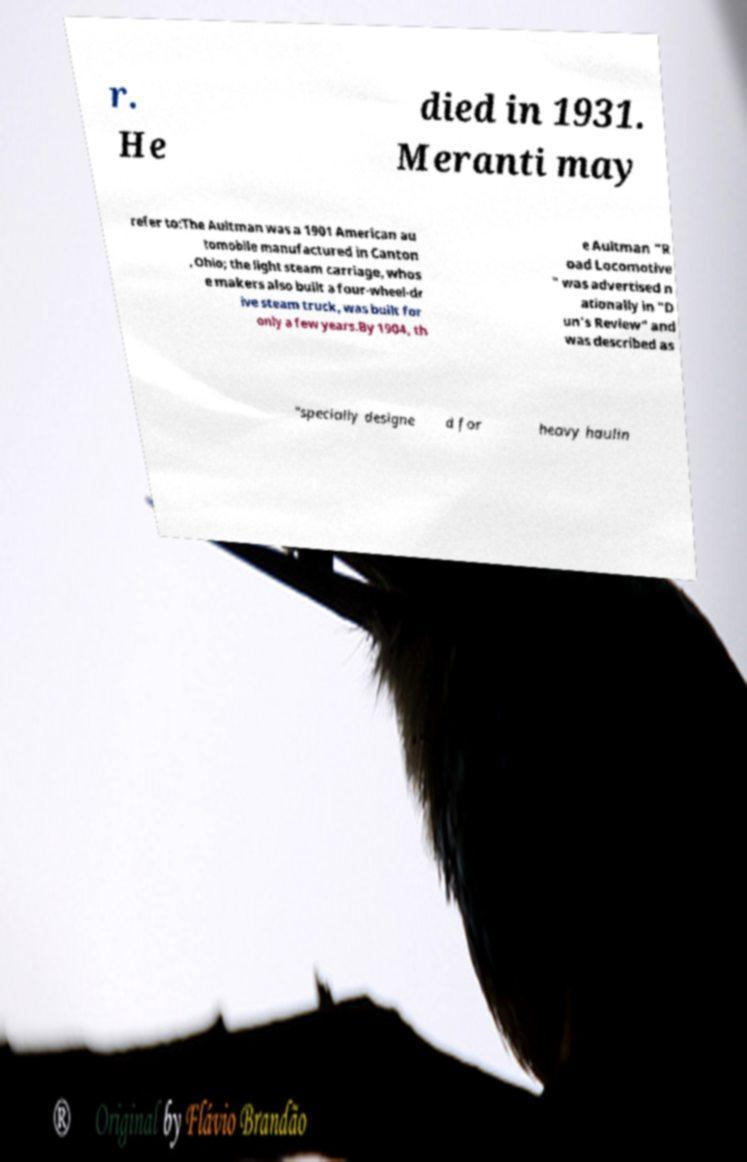Could you assist in decoding the text presented in this image and type it out clearly? r. He died in 1931. Meranti may refer to:The Aultman was a 1901 American au tomobile manufactured in Canton , Ohio; the light steam carriage, whos e makers also built a four-wheel-dr ive steam truck, was built for only a few years.By 1904, th e Aultman "R oad Locomotive " was advertised n ationally in "D un's Review" and was described as "specially designe d for heavy haulin 